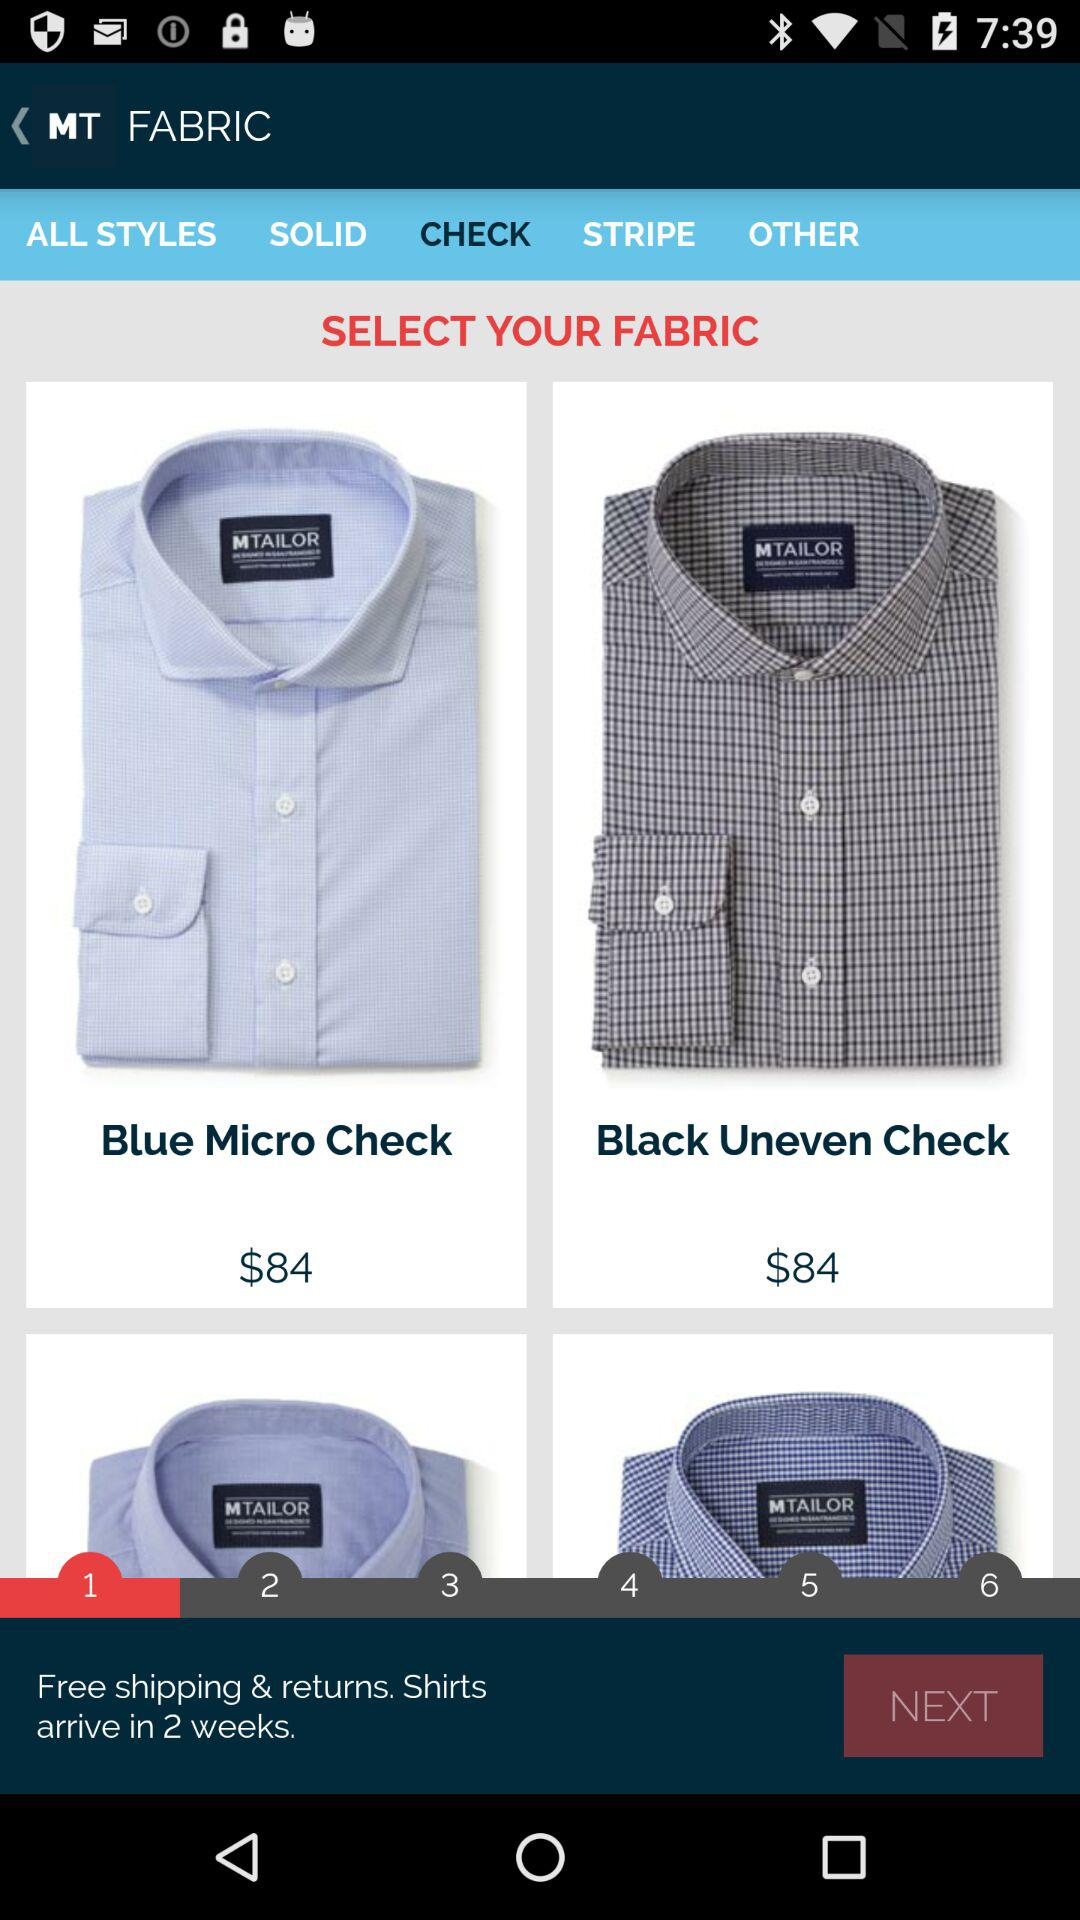How many weeks will it take to ship the shirts? It will take 2 weeks to ship the shirts. 